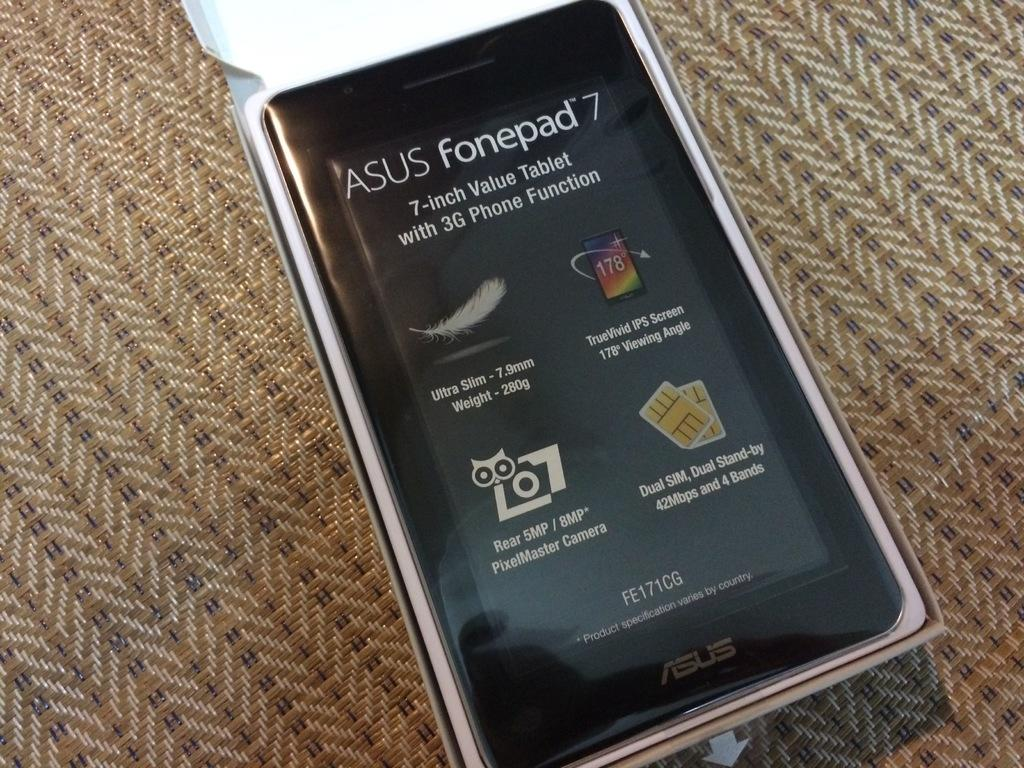Provide a one-sentence caption for the provided image. An Asus fonepad 7 device placed on a woven fabric. 